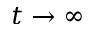Convert formula to latex. <formula><loc_0><loc_0><loc_500><loc_500>t \rightarrow \infty</formula> 